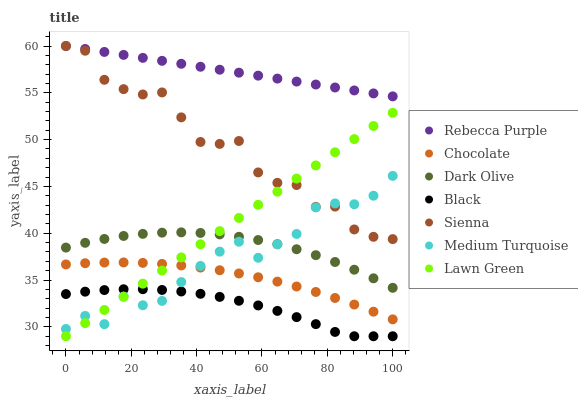Does Black have the minimum area under the curve?
Answer yes or no. Yes. Does Rebecca Purple have the maximum area under the curve?
Answer yes or no. Yes. Does Dark Olive have the minimum area under the curve?
Answer yes or no. No. Does Dark Olive have the maximum area under the curve?
Answer yes or no. No. Is Rebecca Purple the smoothest?
Answer yes or no. Yes. Is Sienna the roughest?
Answer yes or no. Yes. Is Dark Olive the smoothest?
Answer yes or no. No. Is Dark Olive the roughest?
Answer yes or no. No. Does Lawn Green have the lowest value?
Answer yes or no. Yes. Does Dark Olive have the lowest value?
Answer yes or no. No. Does Rebecca Purple have the highest value?
Answer yes or no. Yes. Does Dark Olive have the highest value?
Answer yes or no. No. Is Black less than Chocolate?
Answer yes or no. Yes. Is Rebecca Purple greater than Medium Turquoise?
Answer yes or no. Yes. Does Medium Turquoise intersect Lawn Green?
Answer yes or no. Yes. Is Medium Turquoise less than Lawn Green?
Answer yes or no. No. Is Medium Turquoise greater than Lawn Green?
Answer yes or no. No. Does Black intersect Chocolate?
Answer yes or no. No. 